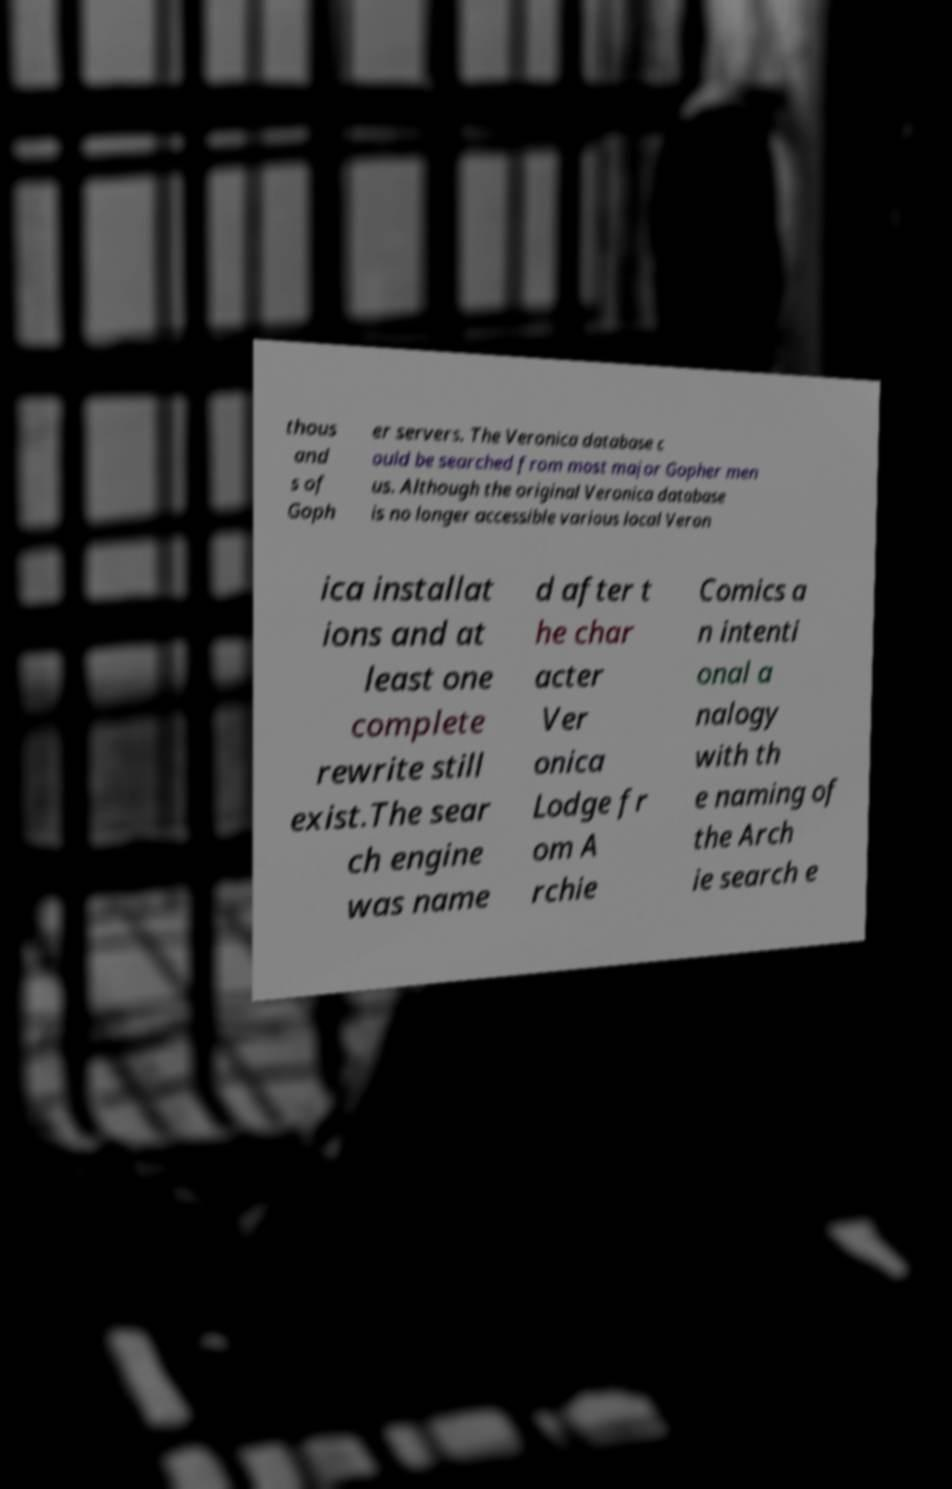I need the written content from this picture converted into text. Can you do that? thous and s of Goph er servers. The Veronica database c ould be searched from most major Gopher men us. Although the original Veronica database is no longer accessible various local Veron ica installat ions and at least one complete rewrite still exist.The sear ch engine was name d after t he char acter Ver onica Lodge fr om A rchie Comics a n intenti onal a nalogy with th e naming of the Arch ie search e 